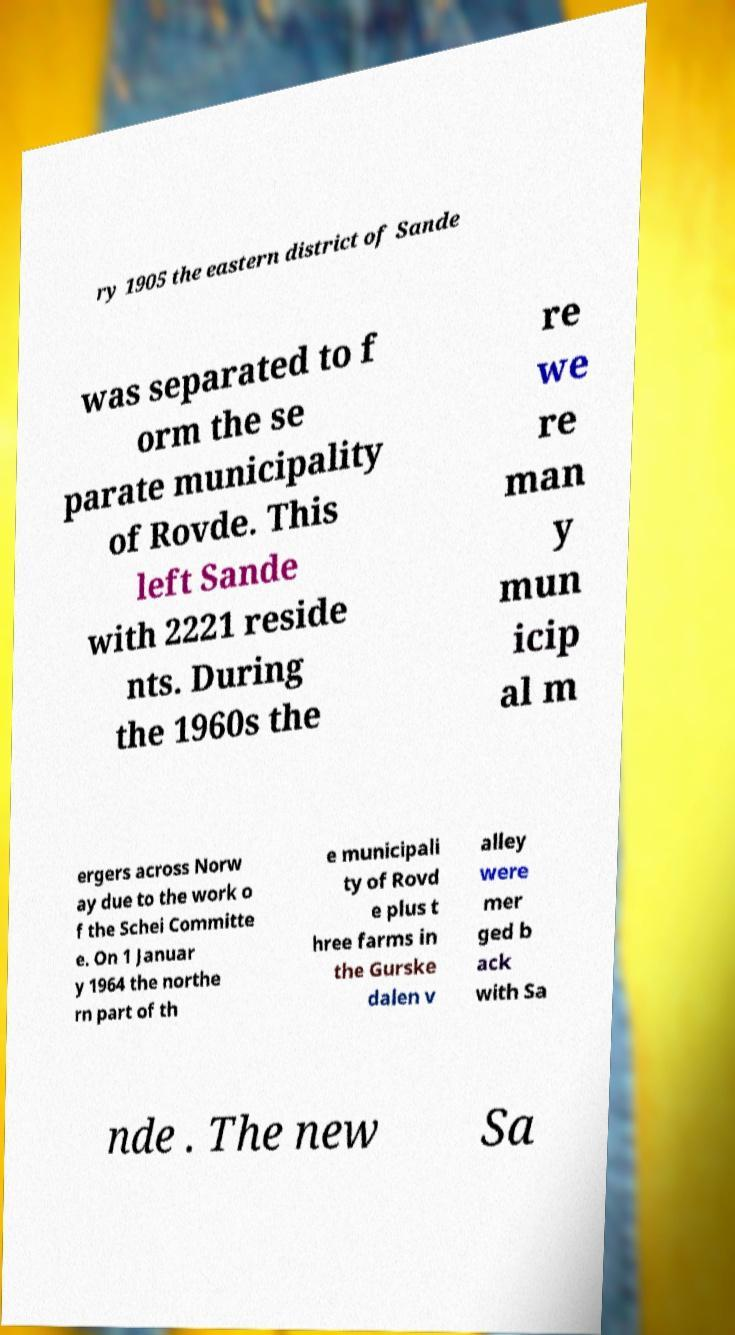I need the written content from this picture converted into text. Can you do that? ry 1905 the eastern district of Sande was separated to f orm the se parate municipality of Rovde. This left Sande with 2221 reside nts. During the 1960s the re we re man y mun icip al m ergers across Norw ay due to the work o f the Schei Committe e. On 1 Januar y 1964 the northe rn part of th e municipali ty of Rovd e plus t hree farms in the Gurske dalen v alley were mer ged b ack with Sa nde . The new Sa 